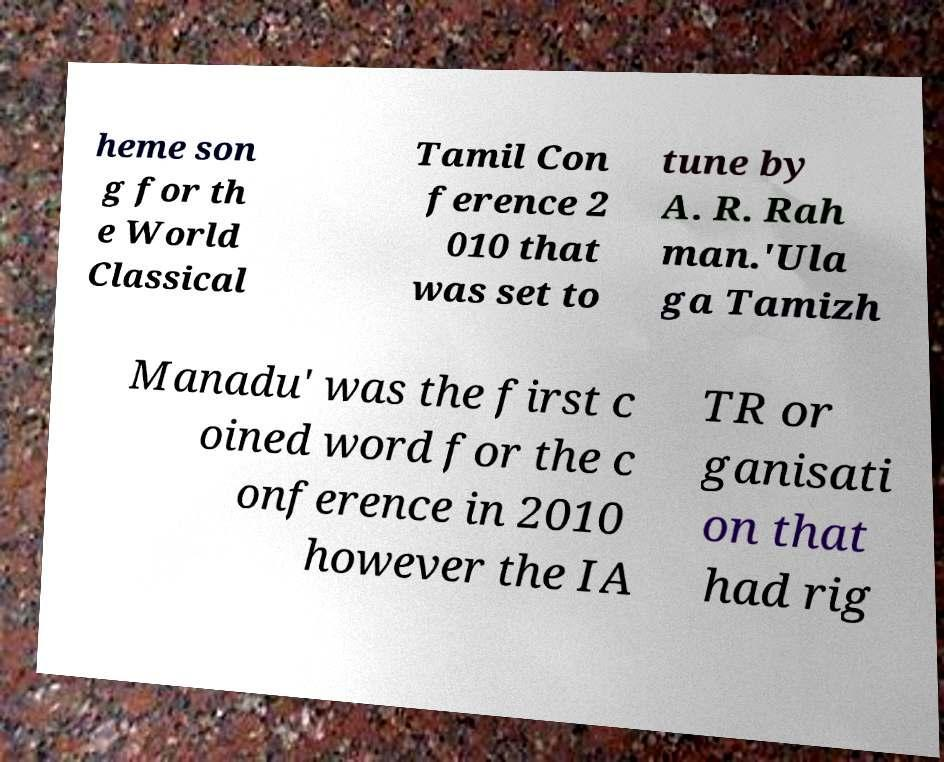What messages or text are displayed in this image? I need them in a readable, typed format. heme son g for th e World Classical Tamil Con ference 2 010 that was set to tune by A. R. Rah man.'Ula ga Tamizh Manadu' was the first c oined word for the c onference in 2010 however the IA TR or ganisati on that had rig 